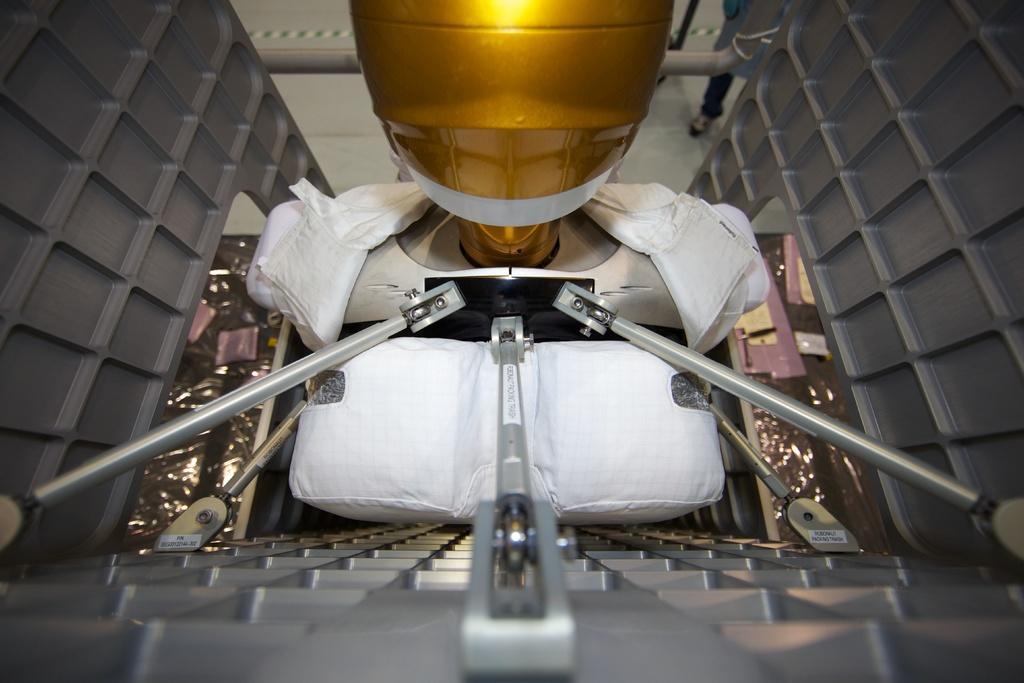Please provide a concise description of this image. In the picture I can see a machine equipment. I can see the gold color object at the top of the picture. I can see the white color cloth. 